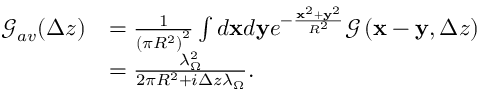<formula> <loc_0><loc_0><loc_500><loc_500>\begin{array} { r l } { \mathcal { G } _ { a v } ( \Delta z ) } & { = \frac { 1 } { \left ( \pi R ^ { 2 } \right ) ^ { 2 } } \int d x d y e ^ { - \frac { x ^ { 2 } + y ^ { 2 } } { R ^ { 2 } } } \mathcal { G } \left ( x - y , \Delta z \right ) } \\ & { = \frac { \lambda _ { \Omega } ^ { 2 } } { 2 \pi R ^ { 2 } + i \Delta z \lambda _ { \Omega } } . } \end{array}</formula> 